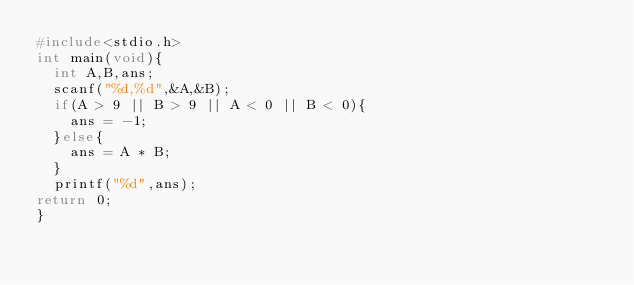Convert code to text. <code><loc_0><loc_0><loc_500><loc_500><_C_>#include<stdio.h>
int main(void){
  int A,B,ans;
  scanf("%d,%d",&A,&B);
  if(A > 9 || B > 9 || A < 0 || B < 0){
    ans = -1;
  }else{
    ans = A * B;
  }
  printf("%d",ans);
return 0;
}</code> 